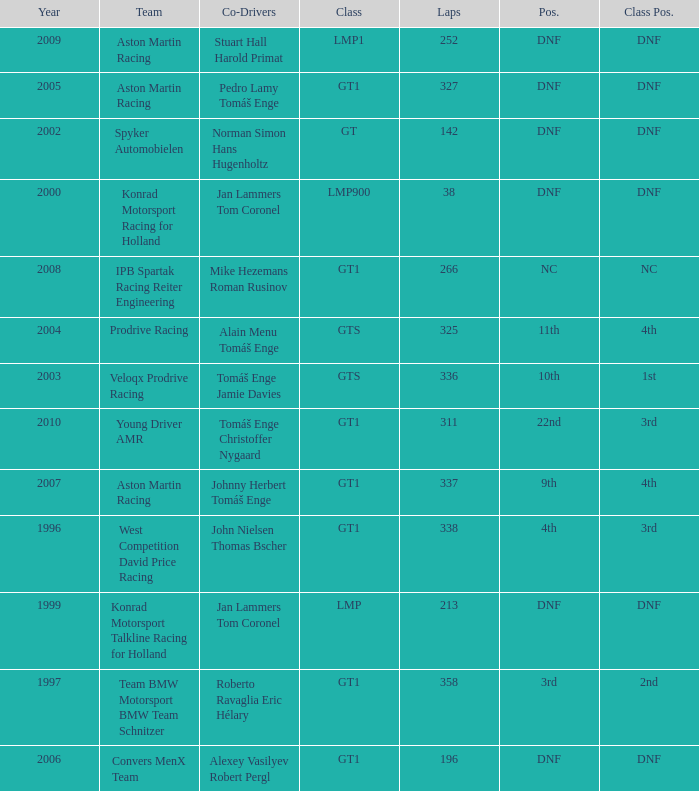Which team finished 3rd in class with 337 laps before 2008? West Competition David Price Racing. 